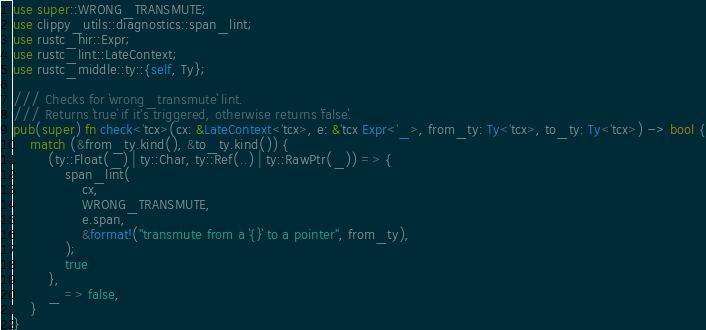<code> <loc_0><loc_0><loc_500><loc_500><_Rust_>use super::WRONG_TRANSMUTE;
use clippy_utils::diagnostics::span_lint;
use rustc_hir::Expr;
use rustc_lint::LateContext;
use rustc_middle::ty::{self, Ty};

/// Checks for `wrong_transmute` lint.
/// Returns `true` if it's triggered, otherwise returns `false`.
pub(super) fn check<'tcx>(cx: &LateContext<'tcx>, e: &'tcx Expr<'_>, from_ty: Ty<'tcx>, to_ty: Ty<'tcx>) -> bool {
    match (&from_ty.kind(), &to_ty.kind()) {
        (ty::Float(_) | ty::Char, ty::Ref(..) | ty::RawPtr(_)) => {
            span_lint(
                cx,
                WRONG_TRANSMUTE,
                e.span,
                &format!("transmute from a `{}` to a pointer", from_ty),
            );
            true
        },
        _ => false,
    }
}
</code> 